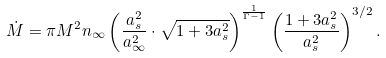<formula> <loc_0><loc_0><loc_500><loc_500>\dot { M } = { \pi } M ^ { 2 } n _ { \infty } \left ( \frac { a _ { s } ^ { 2 } } { a _ { \infty } ^ { 2 } } \cdot \sqrt { 1 + 3 a _ { s } ^ { 2 } } \right ) ^ { \frac { 1 } { \Gamma - 1 } } \left ( \frac { 1 + 3 a _ { s } ^ { 2 } } { a _ { s } ^ { 2 } } \right ) ^ { 3 / 2 } .</formula> 